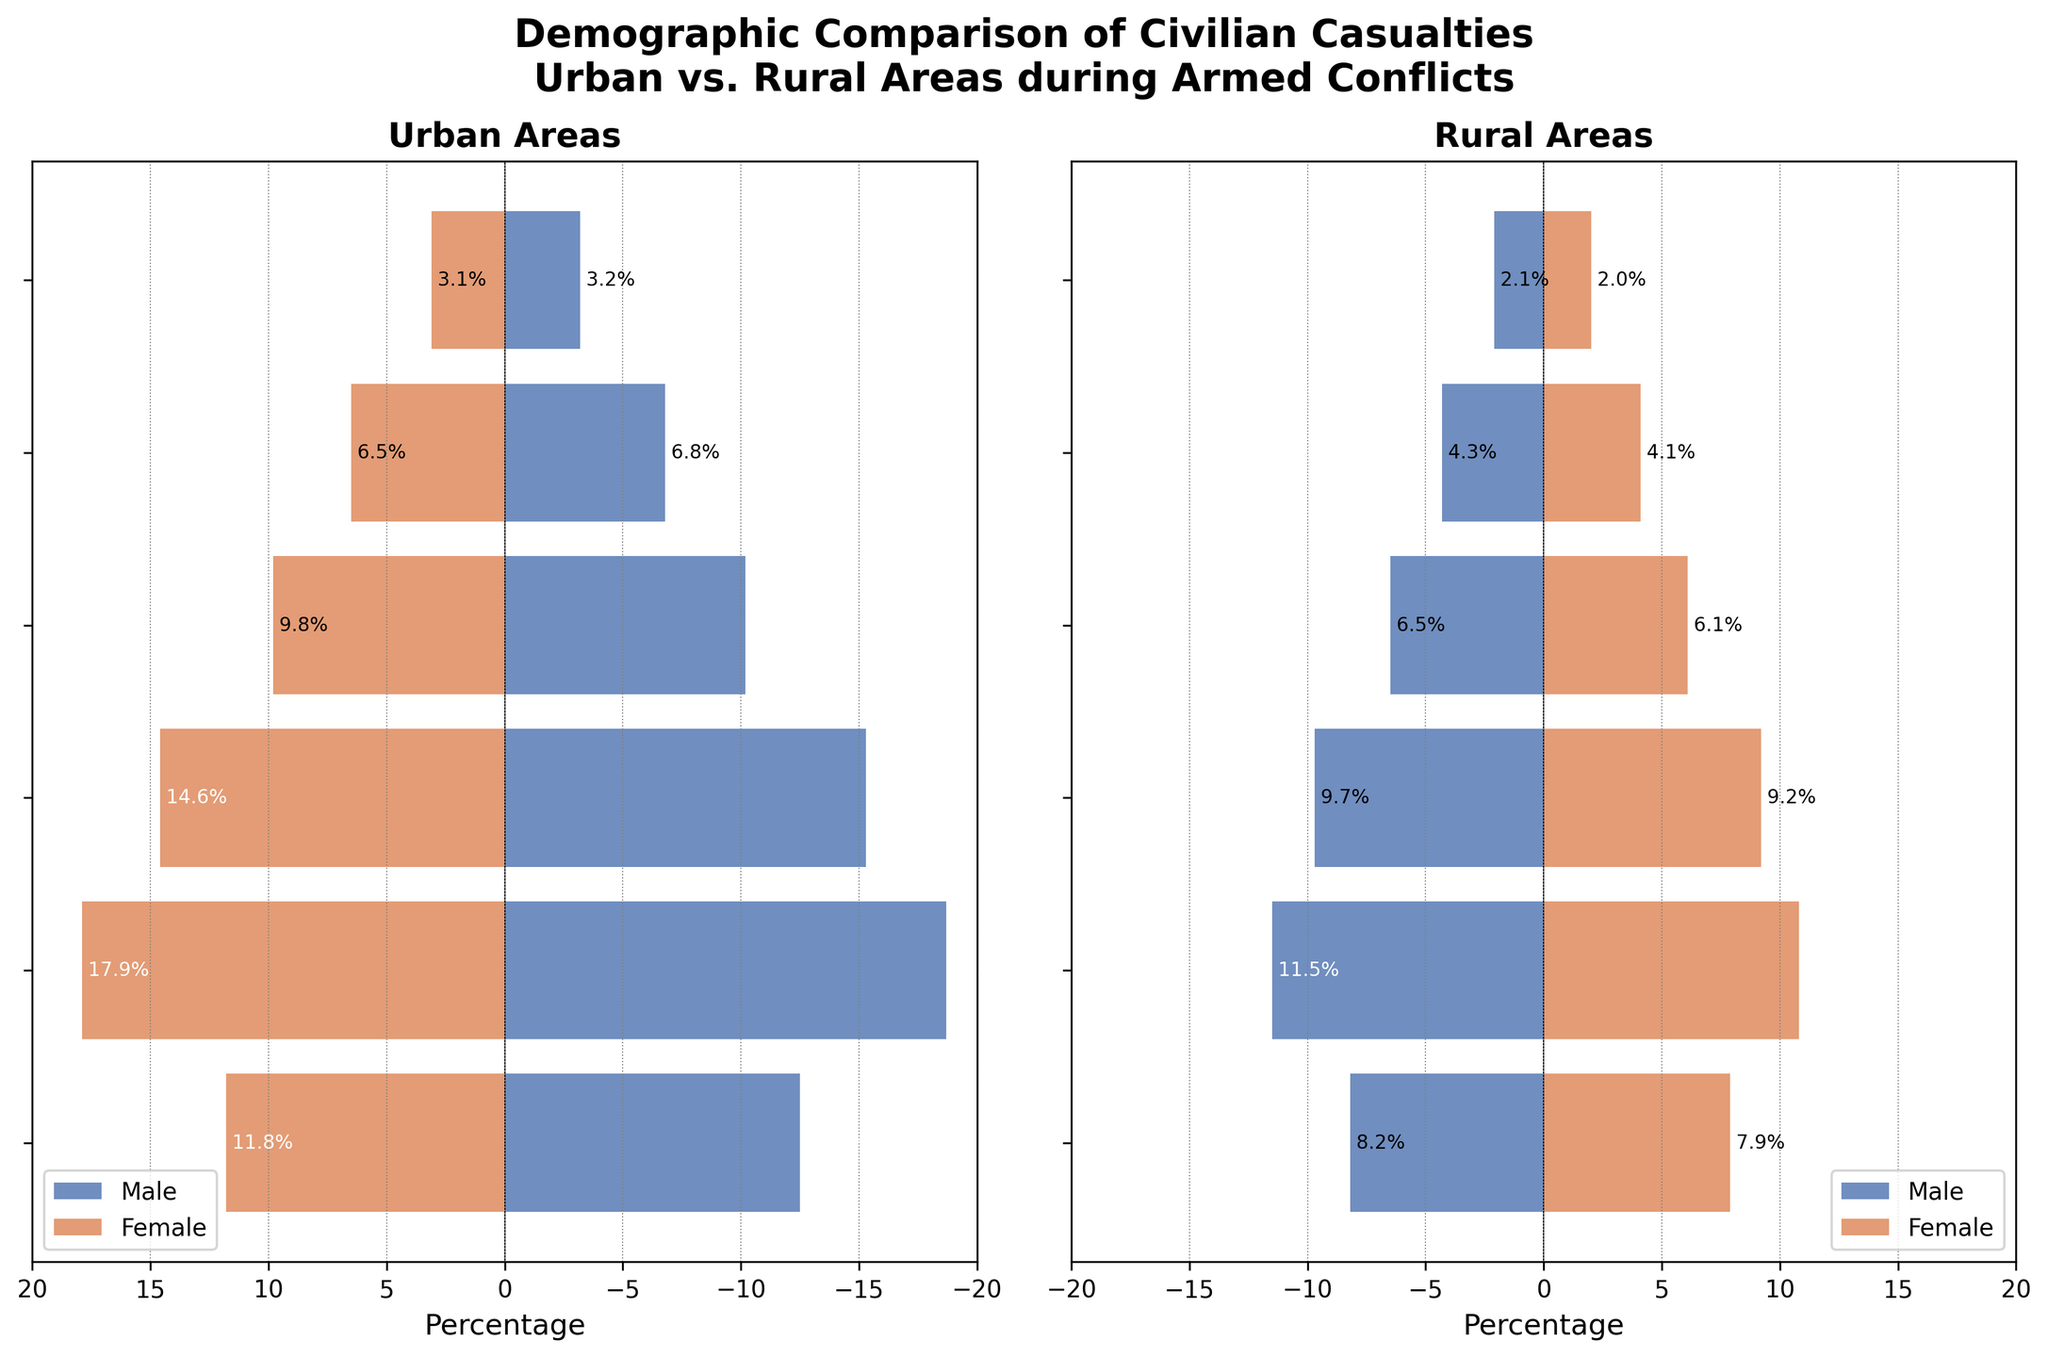What is the title of the figure? The title of the figure is located at the top and summarizes the content of the chart. It reads: "Demographic Comparison of Civilian Casualties Urban vs. Rural Areas during Armed Conflicts"
Answer: Demographic Comparison of Civilian Casualties Urban vs. Rural Areas during Armed Conflicts Which age group has the highest casualty percentage for urban males? To determine the age group with the highest casualty percentage for urban males, we need to look at the lengths of the blue bars on the left side of the urban plot. The longest blue bar will indicate the highest percentage.
Answer: 15-29 How do the casualty percentages of urban females and rural females compare in the 45-59 age group? Compare the lengths of the orange bars in both the urban and rural plots for the 45-59 age group. The urban female bar is slightly longer than the rural female bar.
Answer: Urban females have a higher percentage than rural females What is the combined casualty percentage of urban males in the 0-14 and 15-29 age groups? To find the combined percentage, sum the percentages for the 0-14 and 15-29 age groups for urban males. The percentages are -12.5% and -18.7%, respectively. Combined: -12.5 + -18.7 = -31.2%
Answer: -31.2% Which age group shows a larger discrepancy in casualty percentages between urban and rural females? By looking at the difference in lengths of the orange bars for each age group in the urban and rural plots, the age group 15-29 shows a larger discrepancy. Urban females have 17.9% compared to rural females with 10.8%.
Answer: 15-29 In which age group do rural males have the least casualty percentage? To find the age group with the least casualty percentage for rural males, identify the shortest blue bar on the right side of the rural plot. The shortest blue bar is in the 75+ age group.
Answer: 75+ Compare the casualty percentages of urban males and females in the 60-74 age group. Checking the lengths of the blue and orange bars for the 60-74 age group in the urban plot, urban males have a casualty percentage of -6.8%, and urban females have a casualty percentage of 6.5%.
Answer: Urban males have -6.8% and urban females have 6.5% Which gender has a higher overall casualty percentage in rural areas? By comparing the total lengths of the blue (male) and orange (female) bars across all age groups in the rural plot, rural males have consistently longer bars.
Answer: Males What is the urban female casualty for the 45-59 age group? Locate the orange bar corresponding to the 45-59 age group in the urban plot. The label on the bar indicates it is 9.8%.
Answer: 9.8% 